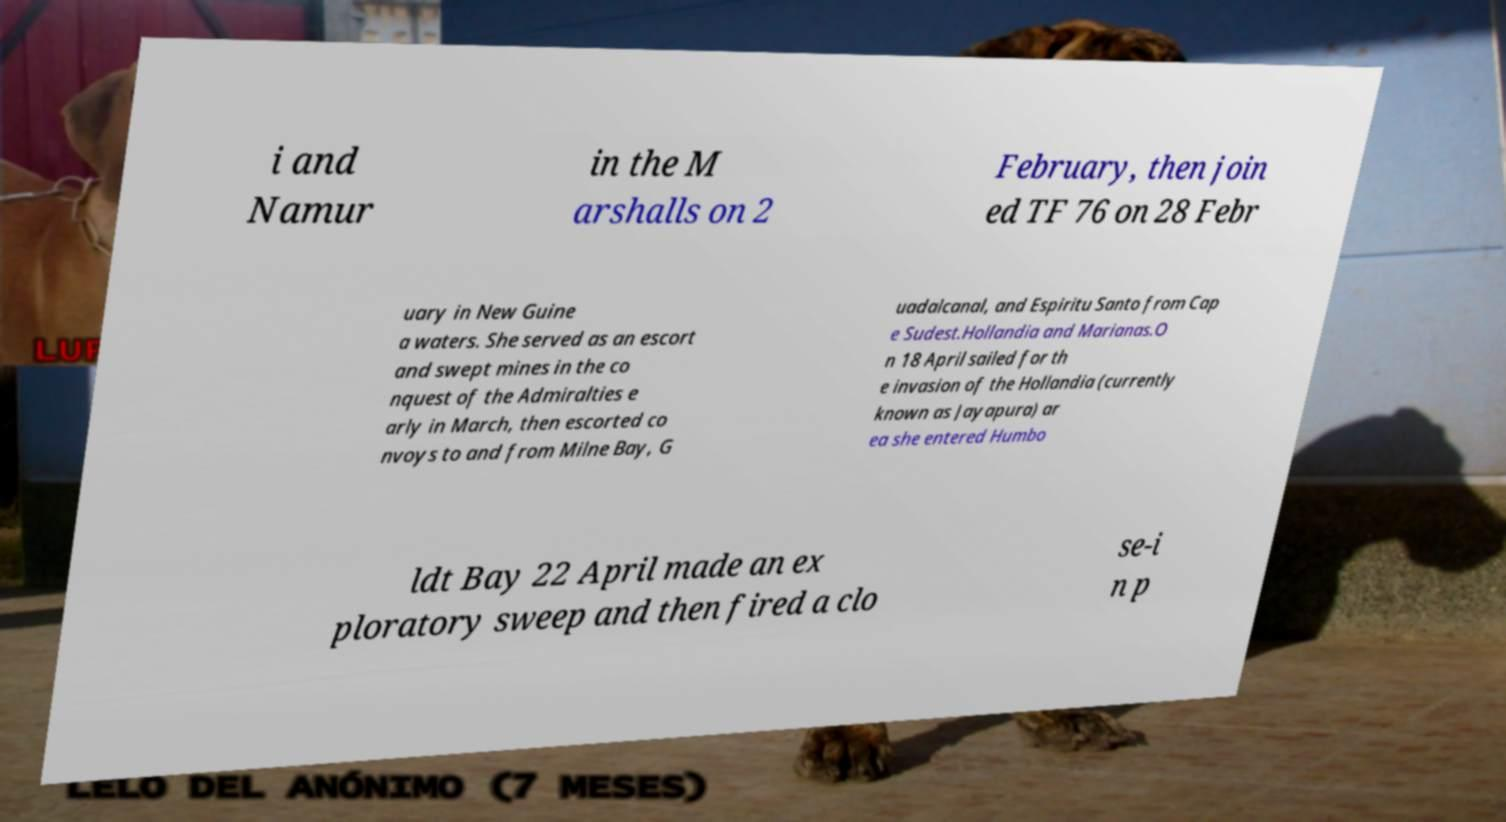What messages or text are displayed in this image? I need them in a readable, typed format. i and Namur in the M arshalls on 2 February, then join ed TF 76 on 28 Febr uary in New Guine a waters. She served as an escort and swept mines in the co nquest of the Admiralties e arly in March, then escorted co nvoys to and from Milne Bay, G uadalcanal, and Espiritu Santo from Cap e Sudest.Hollandia and Marianas.O n 18 April sailed for th e invasion of the Hollandia (currently known as Jayapura) ar ea she entered Humbo ldt Bay 22 April made an ex ploratory sweep and then fired a clo se-i n p 